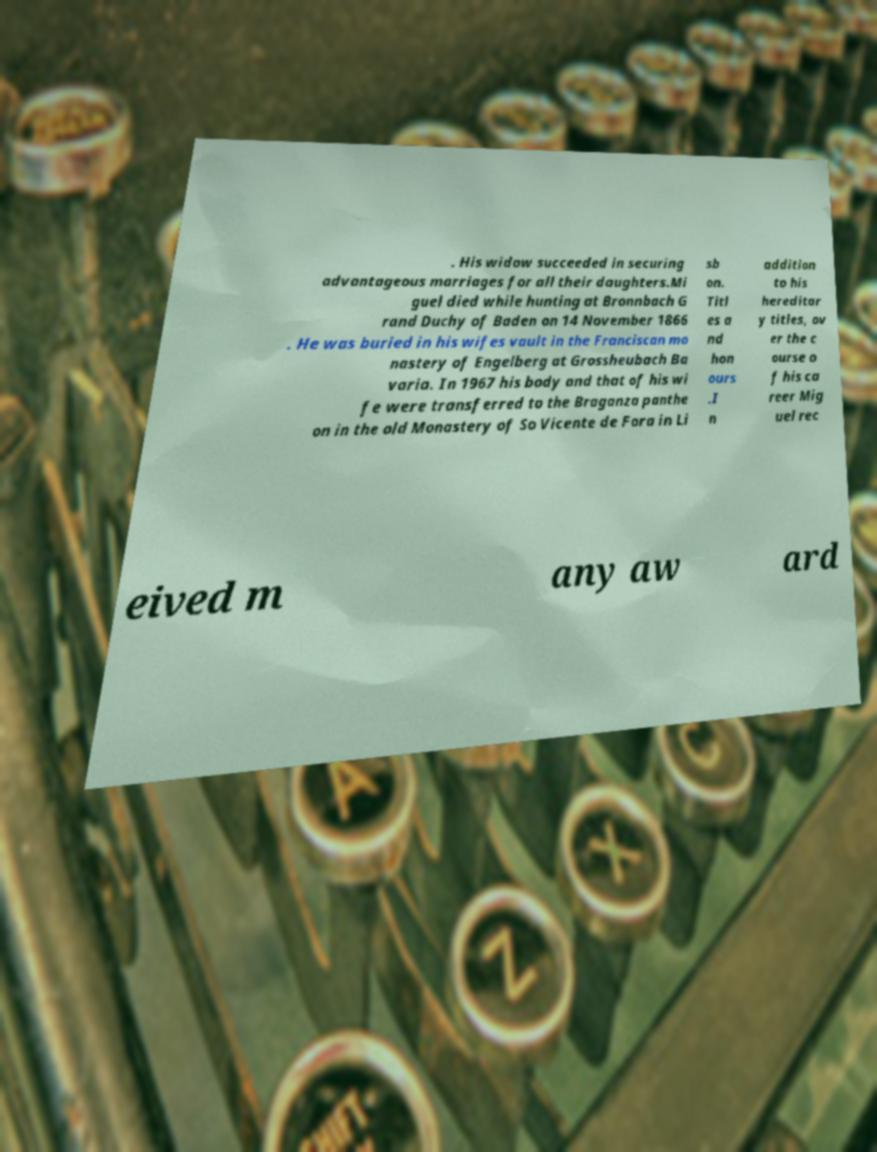Can you read and provide the text displayed in the image?This photo seems to have some interesting text. Can you extract and type it out for me? . His widow succeeded in securing advantageous marriages for all their daughters.Mi guel died while hunting at Bronnbach G rand Duchy of Baden on 14 November 1866 . He was buried in his wifes vault in the Franciscan mo nastery of Engelberg at Grossheubach Ba varia. In 1967 his body and that of his wi fe were transferred to the Braganza panthe on in the old Monastery of So Vicente de Fora in Li sb on. Titl es a nd hon ours .I n addition to his hereditar y titles, ov er the c ourse o f his ca reer Mig uel rec eived m any aw ard 